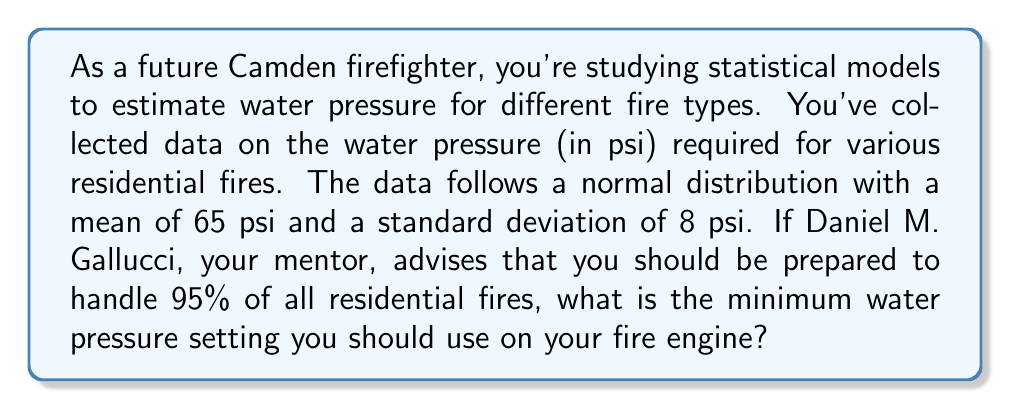Could you help me with this problem? To solve this problem, we need to use the properties of the normal distribution and the concept of z-scores.

1. We know that the data follows a normal distribution with:
   $\mu = 65$ psi (mean)
   $\sigma = 8$ psi (standard deviation)

2. We want to find the value that covers 95% of all cases. This means we're looking for the 95th percentile.

3. In a normal distribution, the area between the mean and a z-score of 1.645 is 0.4750, which represents 47.50% of the data. This means that 95% of the data falls below a z-score of 1.645 (because 50% + 47.50% = 97.50%, and we want 95%).

4. We can use the z-score formula to find the corresponding x-value (water pressure):

   $$z = \frac{x - \mu}{\sigma}$$

   Rearranging this formula, we get:

   $$x = \mu + (z \times \sigma)$$

5. Plugging in our values:

   $$x = 65 + (1.645 \times 8)$$
   $$x = 65 + 13.16$$
   $$x = 78.16$$

Therefore, the minimum water pressure setting should be approximately 78.16 psi to handle 95% of residential fires.
Answer: 78.16 psi 